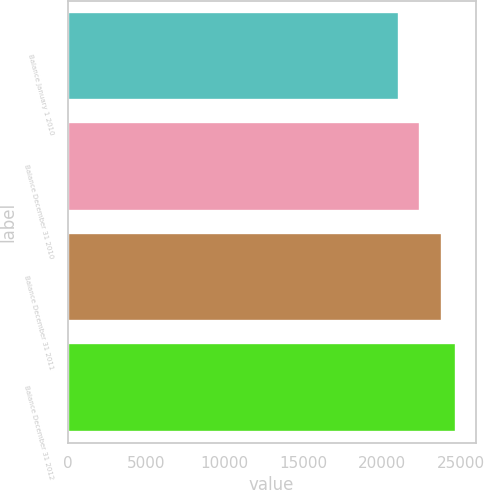Convert chart to OTSL. <chart><loc_0><loc_0><loc_500><loc_500><bar_chart><fcel>Balance January 1 2010<fcel>Balance December 31 2010<fcel>Balance December 31 2011<fcel>Balance December 31 2012<nl><fcel>21044<fcel>22433<fcel>23792<fcel>24717<nl></chart> 